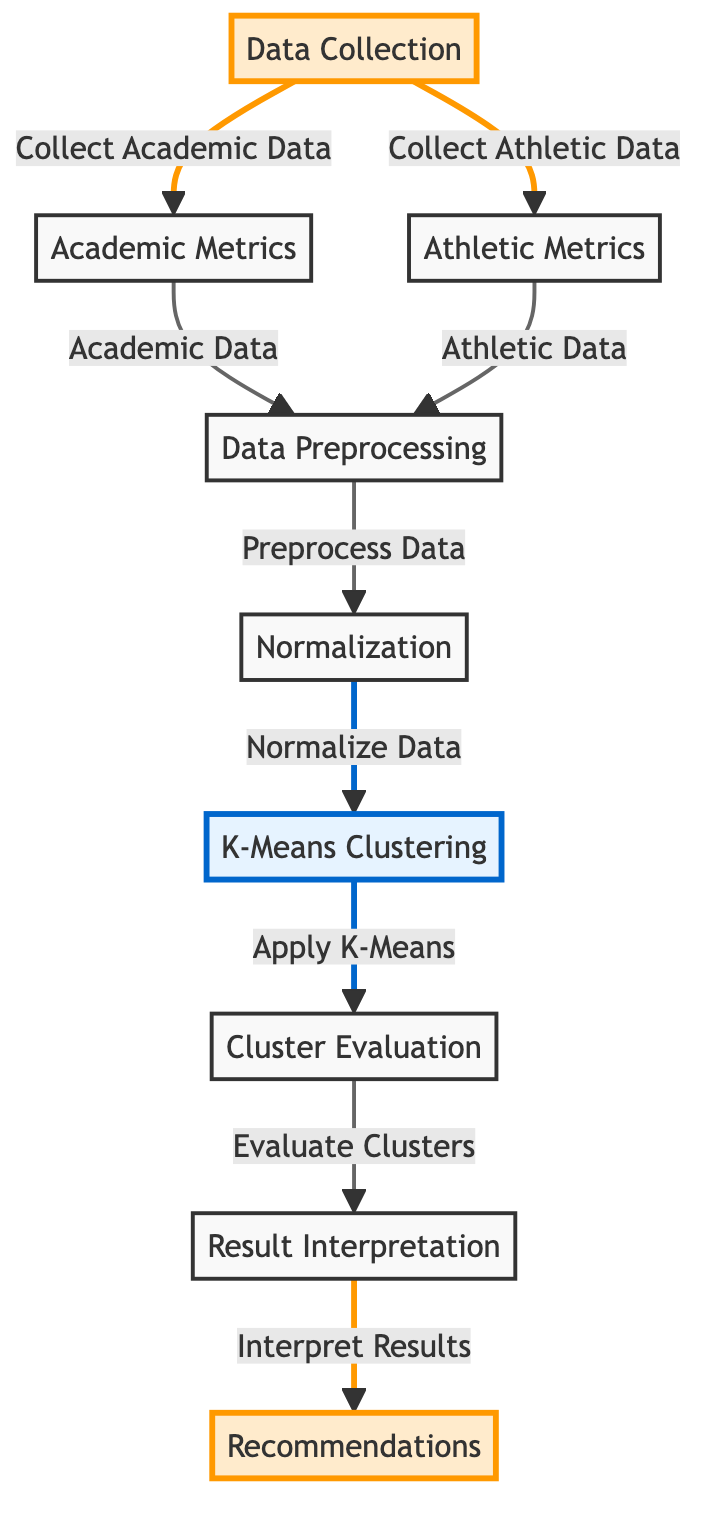What is the first step in the diagram? The first step in the diagram is data collection, which is indicated as the starting point for gathering both academic and athletic data before any other processes.
Answer: data collection How many major processes are shown in the diagram? To determine the number of major processes, one must count all the nodes in the diagram, focusing on those that represent distinct processes. There are a total of 7 distinct processes outlined in the flowchart.
Answer: 7 What type of clustering method is employed in the diagram? The diagram specifies that K-Means clustering is the method used to analyze the data, as this method is highlighted in the flowchart.
Answer: K-Means What is the output of the clustering process? The output of the clustering process, as indicated in the diagram, leads to the evaluation of the clusters formed by the K-Means algorithm.
Answer: Cluster Evaluation Which two types of metrics are collected in the data collection step? The two types of metrics collected in the data collection step are academic metrics and athletic metrics, as specified in the diagram.
Answer: Academic Metrics and Athletic Metrics What process follows normalization in the flow? After the normalization process is completed, the next step in the diagram is the K-Means clustering application to the normalized data.
Answer: Clustering What is the purpose of the evaluation step? The evaluation step's purpose is to assess the clusters generated by the K-Means algorithm to ensure their quality and significance within the analysis.
Answer: Evaluate Clusters What does the interpretation step lead to? The interpretation step in the flowchart leads directly to the recommendations based on the results obtained from the previous processes.
Answer: Recommendations What colors are used to highlight different types of processes in the diagram? The diagram uses distinct colors to signify different types of processes: yellow for data collection and recommendations, and blue for K-Means clustering and interpretation.
Answer: Yellow and Blue 